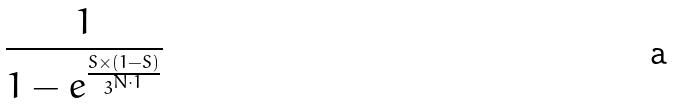<formula> <loc_0><loc_0><loc_500><loc_500>\frac { 1 } { 1 - e ^ { \frac { S \times ( 1 - S ) } { 3 ^ { N \cdot 1 } } } }</formula> 